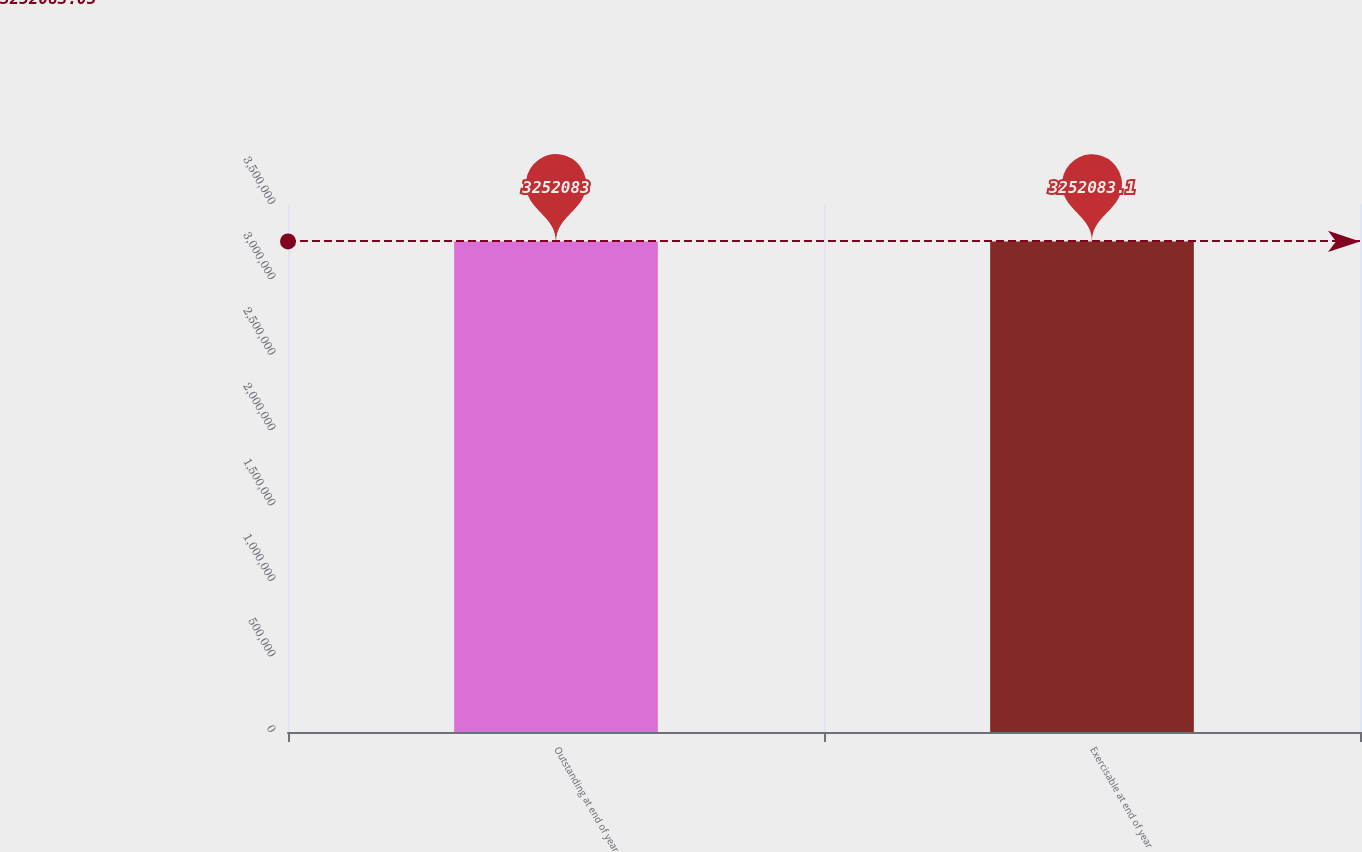<chart> <loc_0><loc_0><loc_500><loc_500><bar_chart><fcel>Outstanding at end of year<fcel>Exercisable at end of year<nl><fcel>3.25208e+06<fcel>3.25208e+06<nl></chart> 